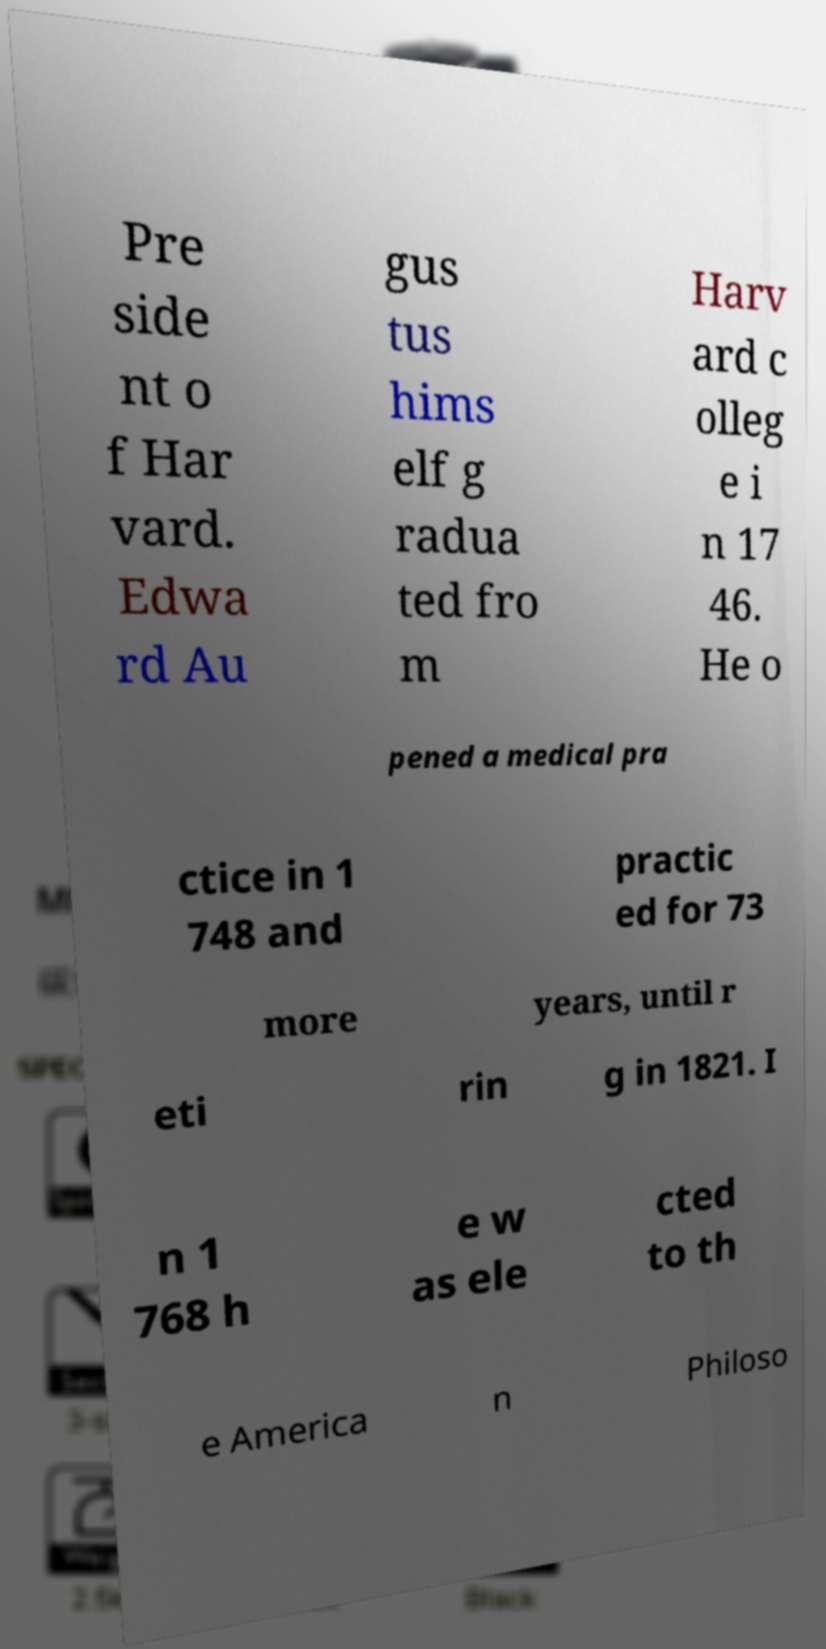What messages or text are displayed in this image? I need them in a readable, typed format. Pre side nt o f Har vard. Edwa rd Au gus tus hims elf g radua ted fro m Harv ard c olleg e i n 17 46. He o pened a medical pra ctice in 1 748 and practic ed for 73 more years, until r eti rin g in 1821. I n 1 768 h e w as ele cted to th e America n Philoso 